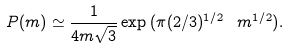Convert formula to latex. <formula><loc_0><loc_0><loc_500><loc_500>P ( m ) \simeq \frac { 1 } { 4 m \sqrt { 3 } } \exp { ( \pi ( 2 / 3 ) ^ { 1 / 2 } \ m ^ { 1 / 2 } ) } .</formula> 